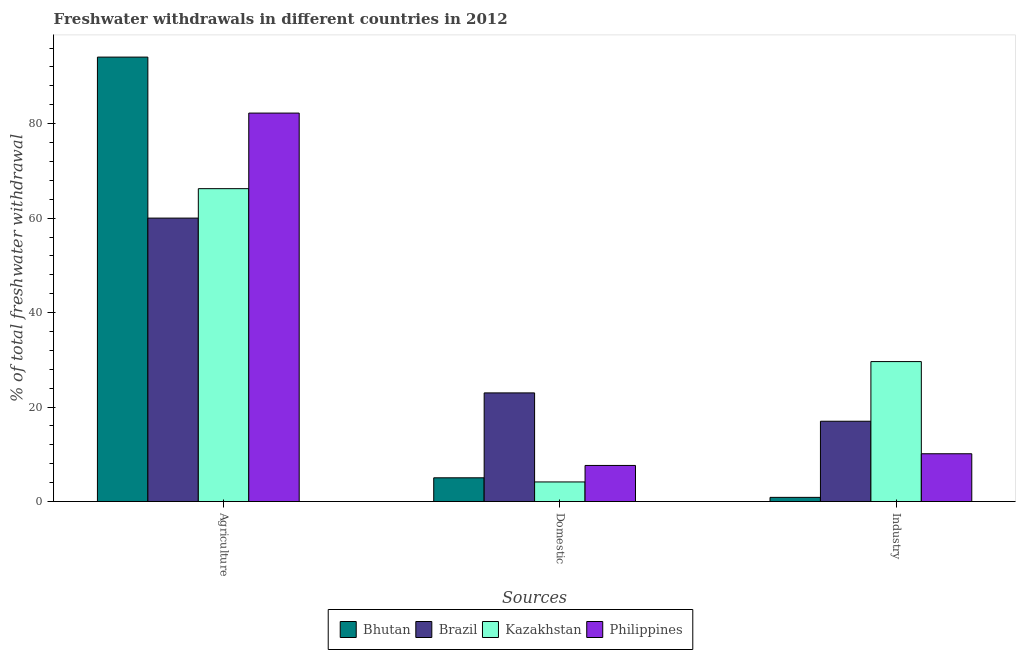How many different coloured bars are there?
Provide a succinct answer. 4. Are the number of bars per tick equal to the number of legend labels?
Offer a very short reply. Yes. Are the number of bars on each tick of the X-axis equal?
Ensure brevity in your answer.  Yes. What is the label of the 1st group of bars from the left?
Provide a succinct answer. Agriculture. What is the percentage of freshwater withdrawal for industry in Bhutan?
Your answer should be compact. 0.89. Across all countries, what is the maximum percentage of freshwater withdrawal for agriculture?
Provide a short and direct response. 94.08. Across all countries, what is the minimum percentage of freshwater withdrawal for domestic purposes?
Keep it short and to the point. 4.15. In which country was the percentage of freshwater withdrawal for agriculture maximum?
Provide a succinct answer. Bhutan. In which country was the percentage of freshwater withdrawal for domestic purposes minimum?
Offer a very short reply. Kazakhstan. What is the total percentage of freshwater withdrawal for industry in the graph?
Give a very brief answer. 57.64. What is the difference between the percentage of freshwater withdrawal for domestic purposes in Philippines and that in Bhutan?
Make the answer very short. 2.61. What is the difference between the percentage of freshwater withdrawal for domestic purposes in Brazil and the percentage of freshwater withdrawal for industry in Philippines?
Offer a terse response. 12.88. What is the average percentage of freshwater withdrawal for agriculture per country?
Your answer should be compact. 75.64. What is the difference between the percentage of freshwater withdrawal for domestic purposes and percentage of freshwater withdrawal for industry in Kazakhstan?
Give a very brief answer. -25.48. What is the ratio of the percentage of freshwater withdrawal for agriculture in Kazakhstan to that in Brazil?
Provide a succinct answer. 1.1. Is the percentage of freshwater withdrawal for industry in Brazil less than that in Philippines?
Your answer should be very brief. No. Is the difference between the percentage of freshwater withdrawal for domestic purposes in Bhutan and Philippines greater than the difference between the percentage of freshwater withdrawal for industry in Bhutan and Philippines?
Your response must be concise. Yes. What is the difference between the highest and the second highest percentage of freshwater withdrawal for domestic purposes?
Your response must be concise. 15.36. What is the difference between the highest and the lowest percentage of freshwater withdrawal for domestic purposes?
Offer a terse response. 18.85. What does the 4th bar from the left in Agriculture represents?
Offer a very short reply. Philippines. What does the 2nd bar from the right in Domestic represents?
Offer a very short reply. Kazakhstan. Is it the case that in every country, the sum of the percentage of freshwater withdrawal for agriculture and percentage of freshwater withdrawal for domestic purposes is greater than the percentage of freshwater withdrawal for industry?
Ensure brevity in your answer.  Yes. How many countries are there in the graph?
Offer a terse response. 4. Are the values on the major ticks of Y-axis written in scientific E-notation?
Your answer should be very brief. No. Does the graph contain any zero values?
Ensure brevity in your answer.  No. How many legend labels are there?
Provide a short and direct response. 4. How are the legend labels stacked?
Give a very brief answer. Horizontal. What is the title of the graph?
Your response must be concise. Freshwater withdrawals in different countries in 2012. Does "Malta" appear as one of the legend labels in the graph?
Your answer should be very brief. No. What is the label or title of the X-axis?
Offer a very short reply. Sources. What is the label or title of the Y-axis?
Give a very brief answer. % of total freshwater withdrawal. What is the % of total freshwater withdrawal in Bhutan in Agriculture?
Keep it short and to the point. 94.08. What is the % of total freshwater withdrawal in Brazil in Agriculture?
Ensure brevity in your answer.  60. What is the % of total freshwater withdrawal of Kazakhstan in Agriculture?
Provide a short and direct response. 66.23. What is the % of total freshwater withdrawal in Philippines in Agriculture?
Provide a succinct answer. 82.23. What is the % of total freshwater withdrawal of Bhutan in Domestic?
Ensure brevity in your answer.  5.03. What is the % of total freshwater withdrawal in Kazakhstan in Domestic?
Provide a short and direct response. 4.15. What is the % of total freshwater withdrawal of Philippines in Domestic?
Offer a very short reply. 7.64. What is the % of total freshwater withdrawal in Bhutan in Industry?
Offer a very short reply. 0.89. What is the % of total freshwater withdrawal of Kazakhstan in Industry?
Make the answer very short. 29.63. What is the % of total freshwater withdrawal in Philippines in Industry?
Provide a short and direct response. 10.12. Across all Sources, what is the maximum % of total freshwater withdrawal in Bhutan?
Ensure brevity in your answer.  94.08. Across all Sources, what is the maximum % of total freshwater withdrawal in Brazil?
Offer a very short reply. 60. Across all Sources, what is the maximum % of total freshwater withdrawal in Kazakhstan?
Keep it short and to the point. 66.23. Across all Sources, what is the maximum % of total freshwater withdrawal of Philippines?
Ensure brevity in your answer.  82.23. Across all Sources, what is the minimum % of total freshwater withdrawal of Bhutan?
Offer a terse response. 0.89. Across all Sources, what is the minimum % of total freshwater withdrawal of Brazil?
Your response must be concise. 17. Across all Sources, what is the minimum % of total freshwater withdrawal of Kazakhstan?
Keep it short and to the point. 4.15. Across all Sources, what is the minimum % of total freshwater withdrawal in Philippines?
Provide a succinct answer. 7.64. What is the total % of total freshwater withdrawal of Bhutan in the graph?
Your answer should be very brief. 100. What is the total % of total freshwater withdrawal in Kazakhstan in the graph?
Give a very brief answer. 100.01. What is the total % of total freshwater withdrawal in Philippines in the graph?
Your response must be concise. 100. What is the difference between the % of total freshwater withdrawal in Bhutan in Agriculture and that in Domestic?
Offer a terse response. 89.05. What is the difference between the % of total freshwater withdrawal in Brazil in Agriculture and that in Domestic?
Make the answer very short. 37. What is the difference between the % of total freshwater withdrawal in Kazakhstan in Agriculture and that in Domestic?
Offer a very short reply. 62.08. What is the difference between the % of total freshwater withdrawal in Philippines in Agriculture and that in Domestic?
Keep it short and to the point. 74.58. What is the difference between the % of total freshwater withdrawal in Bhutan in Agriculture and that in Industry?
Your answer should be compact. 93.19. What is the difference between the % of total freshwater withdrawal in Kazakhstan in Agriculture and that in Industry?
Make the answer very short. 36.6. What is the difference between the % of total freshwater withdrawal in Philippines in Agriculture and that in Industry?
Keep it short and to the point. 72.11. What is the difference between the % of total freshwater withdrawal of Bhutan in Domestic and that in Industry?
Your response must be concise. 4.14. What is the difference between the % of total freshwater withdrawal of Brazil in Domestic and that in Industry?
Give a very brief answer. 6. What is the difference between the % of total freshwater withdrawal in Kazakhstan in Domestic and that in Industry?
Provide a succinct answer. -25.48. What is the difference between the % of total freshwater withdrawal of Philippines in Domestic and that in Industry?
Give a very brief answer. -2.48. What is the difference between the % of total freshwater withdrawal of Bhutan in Agriculture and the % of total freshwater withdrawal of Brazil in Domestic?
Offer a terse response. 71.08. What is the difference between the % of total freshwater withdrawal in Bhutan in Agriculture and the % of total freshwater withdrawal in Kazakhstan in Domestic?
Make the answer very short. 89.93. What is the difference between the % of total freshwater withdrawal of Bhutan in Agriculture and the % of total freshwater withdrawal of Philippines in Domestic?
Provide a succinct answer. 86.44. What is the difference between the % of total freshwater withdrawal of Brazil in Agriculture and the % of total freshwater withdrawal of Kazakhstan in Domestic?
Keep it short and to the point. 55.85. What is the difference between the % of total freshwater withdrawal in Brazil in Agriculture and the % of total freshwater withdrawal in Philippines in Domestic?
Your response must be concise. 52.35. What is the difference between the % of total freshwater withdrawal in Kazakhstan in Agriculture and the % of total freshwater withdrawal in Philippines in Domestic?
Your answer should be very brief. 58.59. What is the difference between the % of total freshwater withdrawal of Bhutan in Agriculture and the % of total freshwater withdrawal of Brazil in Industry?
Offer a very short reply. 77.08. What is the difference between the % of total freshwater withdrawal in Bhutan in Agriculture and the % of total freshwater withdrawal in Kazakhstan in Industry?
Offer a very short reply. 64.45. What is the difference between the % of total freshwater withdrawal in Bhutan in Agriculture and the % of total freshwater withdrawal in Philippines in Industry?
Your answer should be very brief. 83.96. What is the difference between the % of total freshwater withdrawal in Brazil in Agriculture and the % of total freshwater withdrawal in Kazakhstan in Industry?
Your answer should be very brief. 30.37. What is the difference between the % of total freshwater withdrawal in Brazil in Agriculture and the % of total freshwater withdrawal in Philippines in Industry?
Offer a terse response. 49.88. What is the difference between the % of total freshwater withdrawal in Kazakhstan in Agriculture and the % of total freshwater withdrawal in Philippines in Industry?
Your response must be concise. 56.11. What is the difference between the % of total freshwater withdrawal in Bhutan in Domestic and the % of total freshwater withdrawal in Brazil in Industry?
Make the answer very short. -11.97. What is the difference between the % of total freshwater withdrawal in Bhutan in Domestic and the % of total freshwater withdrawal in Kazakhstan in Industry?
Offer a terse response. -24.6. What is the difference between the % of total freshwater withdrawal in Bhutan in Domestic and the % of total freshwater withdrawal in Philippines in Industry?
Your answer should be compact. -5.09. What is the difference between the % of total freshwater withdrawal of Brazil in Domestic and the % of total freshwater withdrawal of Kazakhstan in Industry?
Your answer should be compact. -6.63. What is the difference between the % of total freshwater withdrawal of Brazil in Domestic and the % of total freshwater withdrawal of Philippines in Industry?
Provide a succinct answer. 12.88. What is the difference between the % of total freshwater withdrawal of Kazakhstan in Domestic and the % of total freshwater withdrawal of Philippines in Industry?
Give a very brief answer. -5.97. What is the average % of total freshwater withdrawal in Bhutan per Sources?
Your response must be concise. 33.33. What is the average % of total freshwater withdrawal of Brazil per Sources?
Your response must be concise. 33.33. What is the average % of total freshwater withdrawal of Kazakhstan per Sources?
Provide a succinct answer. 33.34. What is the average % of total freshwater withdrawal in Philippines per Sources?
Ensure brevity in your answer.  33.33. What is the difference between the % of total freshwater withdrawal of Bhutan and % of total freshwater withdrawal of Brazil in Agriculture?
Ensure brevity in your answer.  34.08. What is the difference between the % of total freshwater withdrawal of Bhutan and % of total freshwater withdrawal of Kazakhstan in Agriculture?
Keep it short and to the point. 27.85. What is the difference between the % of total freshwater withdrawal in Bhutan and % of total freshwater withdrawal in Philippines in Agriculture?
Make the answer very short. 11.85. What is the difference between the % of total freshwater withdrawal of Brazil and % of total freshwater withdrawal of Kazakhstan in Agriculture?
Your answer should be very brief. -6.23. What is the difference between the % of total freshwater withdrawal of Brazil and % of total freshwater withdrawal of Philippines in Agriculture?
Provide a short and direct response. -22.23. What is the difference between the % of total freshwater withdrawal of Kazakhstan and % of total freshwater withdrawal of Philippines in Agriculture?
Keep it short and to the point. -16. What is the difference between the % of total freshwater withdrawal of Bhutan and % of total freshwater withdrawal of Brazil in Domestic?
Offer a very short reply. -17.97. What is the difference between the % of total freshwater withdrawal of Bhutan and % of total freshwater withdrawal of Kazakhstan in Domestic?
Provide a succinct answer. 0.88. What is the difference between the % of total freshwater withdrawal in Bhutan and % of total freshwater withdrawal in Philippines in Domestic?
Your answer should be compact. -2.62. What is the difference between the % of total freshwater withdrawal in Brazil and % of total freshwater withdrawal in Kazakhstan in Domestic?
Keep it short and to the point. 18.85. What is the difference between the % of total freshwater withdrawal in Brazil and % of total freshwater withdrawal in Philippines in Domestic?
Make the answer very short. 15.36. What is the difference between the % of total freshwater withdrawal of Kazakhstan and % of total freshwater withdrawal of Philippines in Domestic?
Make the answer very short. -3.49. What is the difference between the % of total freshwater withdrawal of Bhutan and % of total freshwater withdrawal of Brazil in Industry?
Provide a short and direct response. -16.11. What is the difference between the % of total freshwater withdrawal in Bhutan and % of total freshwater withdrawal in Kazakhstan in Industry?
Provide a short and direct response. -28.74. What is the difference between the % of total freshwater withdrawal in Bhutan and % of total freshwater withdrawal in Philippines in Industry?
Your response must be concise. -9.23. What is the difference between the % of total freshwater withdrawal of Brazil and % of total freshwater withdrawal of Kazakhstan in Industry?
Provide a short and direct response. -12.63. What is the difference between the % of total freshwater withdrawal in Brazil and % of total freshwater withdrawal in Philippines in Industry?
Provide a short and direct response. 6.88. What is the difference between the % of total freshwater withdrawal in Kazakhstan and % of total freshwater withdrawal in Philippines in Industry?
Your answer should be compact. 19.51. What is the ratio of the % of total freshwater withdrawal of Bhutan in Agriculture to that in Domestic?
Your response must be concise. 18.7. What is the ratio of the % of total freshwater withdrawal of Brazil in Agriculture to that in Domestic?
Ensure brevity in your answer.  2.61. What is the ratio of the % of total freshwater withdrawal in Kazakhstan in Agriculture to that in Domestic?
Give a very brief answer. 15.95. What is the ratio of the % of total freshwater withdrawal of Philippines in Agriculture to that in Domestic?
Provide a succinct answer. 10.76. What is the ratio of the % of total freshwater withdrawal in Bhutan in Agriculture to that in Industry?
Give a very brief answer. 105.99. What is the ratio of the % of total freshwater withdrawal in Brazil in Agriculture to that in Industry?
Keep it short and to the point. 3.53. What is the ratio of the % of total freshwater withdrawal of Kazakhstan in Agriculture to that in Industry?
Offer a very short reply. 2.24. What is the ratio of the % of total freshwater withdrawal in Philippines in Agriculture to that in Industry?
Give a very brief answer. 8.13. What is the ratio of the % of total freshwater withdrawal of Bhutan in Domestic to that in Industry?
Your answer should be very brief. 5.67. What is the ratio of the % of total freshwater withdrawal of Brazil in Domestic to that in Industry?
Provide a short and direct response. 1.35. What is the ratio of the % of total freshwater withdrawal of Kazakhstan in Domestic to that in Industry?
Your answer should be compact. 0.14. What is the ratio of the % of total freshwater withdrawal of Philippines in Domestic to that in Industry?
Keep it short and to the point. 0.76. What is the difference between the highest and the second highest % of total freshwater withdrawal in Bhutan?
Offer a terse response. 89.05. What is the difference between the highest and the second highest % of total freshwater withdrawal in Kazakhstan?
Offer a very short reply. 36.6. What is the difference between the highest and the second highest % of total freshwater withdrawal in Philippines?
Your answer should be compact. 72.11. What is the difference between the highest and the lowest % of total freshwater withdrawal in Bhutan?
Make the answer very short. 93.19. What is the difference between the highest and the lowest % of total freshwater withdrawal in Kazakhstan?
Give a very brief answer. 62.08. What is the difference between the highest and the lowest % of total freshwater withdrawal in Philippines?
Offer a very short reply. 74.58. 